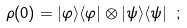<formula> <loc_0><loc_0><loc_500><loc_500>\rho ( 0 ) = | \varphi \rangle \langle \varphi | \otimes | \psi \rangle \langle \psi | \ ;</formula> 